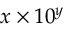<formula> <loc_0><loc_0><loc_500><loc_500>x \times 1 0 ^ { y }</formula> 